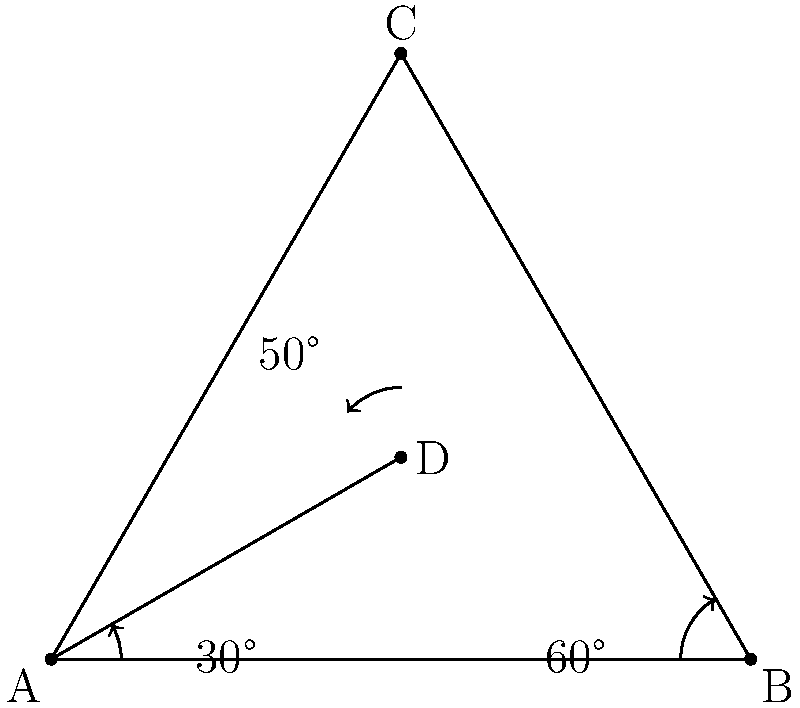During an archaeological excavation in Flowerdale, you've uncovered the foundations of an ancient building. The structure appears to be aligned with certain geographical features. Using the diagram provided, which represents the layout of the foundation, determine the angle between the northern wall (AD) and the eastern wall (AC) of the building. How might this orientation relate to the political significance of the structure in ancient Flowerdale? To solve this problem, we'll follow these steps:

1) First, we need to identify the angle we're looking for. In this case, it's the angle CAD.

2) We can see that the triangle ABC is an equilateral triangle, as it has two angles of 60° marked.

3) In an equilateral triangle, all angles are equal and measure 60°. Therefore, angle BCA is also 60°.

4) We're given that angle DAB is 30°.

5) We know that the sum of angles in a triangle is always 180°. In triangle ACD:

   $$\angle CAD + \angle ACD + \angle CDA = 180°$$

6) We know that $\angle ACD = 60°$ (from step 3) and $\angle CDA = 50°$ (given in the diagram).

7) Let's substitute these values:

   $$\angle CAD + 60° + 50° = 180°$$

8) Solving for $\angle CAD$:

   $$\angle CAD = 180° - 60° - 50° = 70°$$

Therefore, the angle between the northern wall (AD) and the eastern wall (AC) is 70°.

Regarding the political significance, this precise alignment could indicate:

1) The building was oriented towards a specific celestial event, which might have been important for religious or political ceremonies.
2) The alignment might have been towards another significant political structure or geographical feature in ancient Flowerdale.
3) The 70° angle might have had numerical significance in the political or religious system of the time.

This orientation could provide insights into the power structures and belief systems that influenced political decisions in ancient Flowerdale.
Answer: 70° 